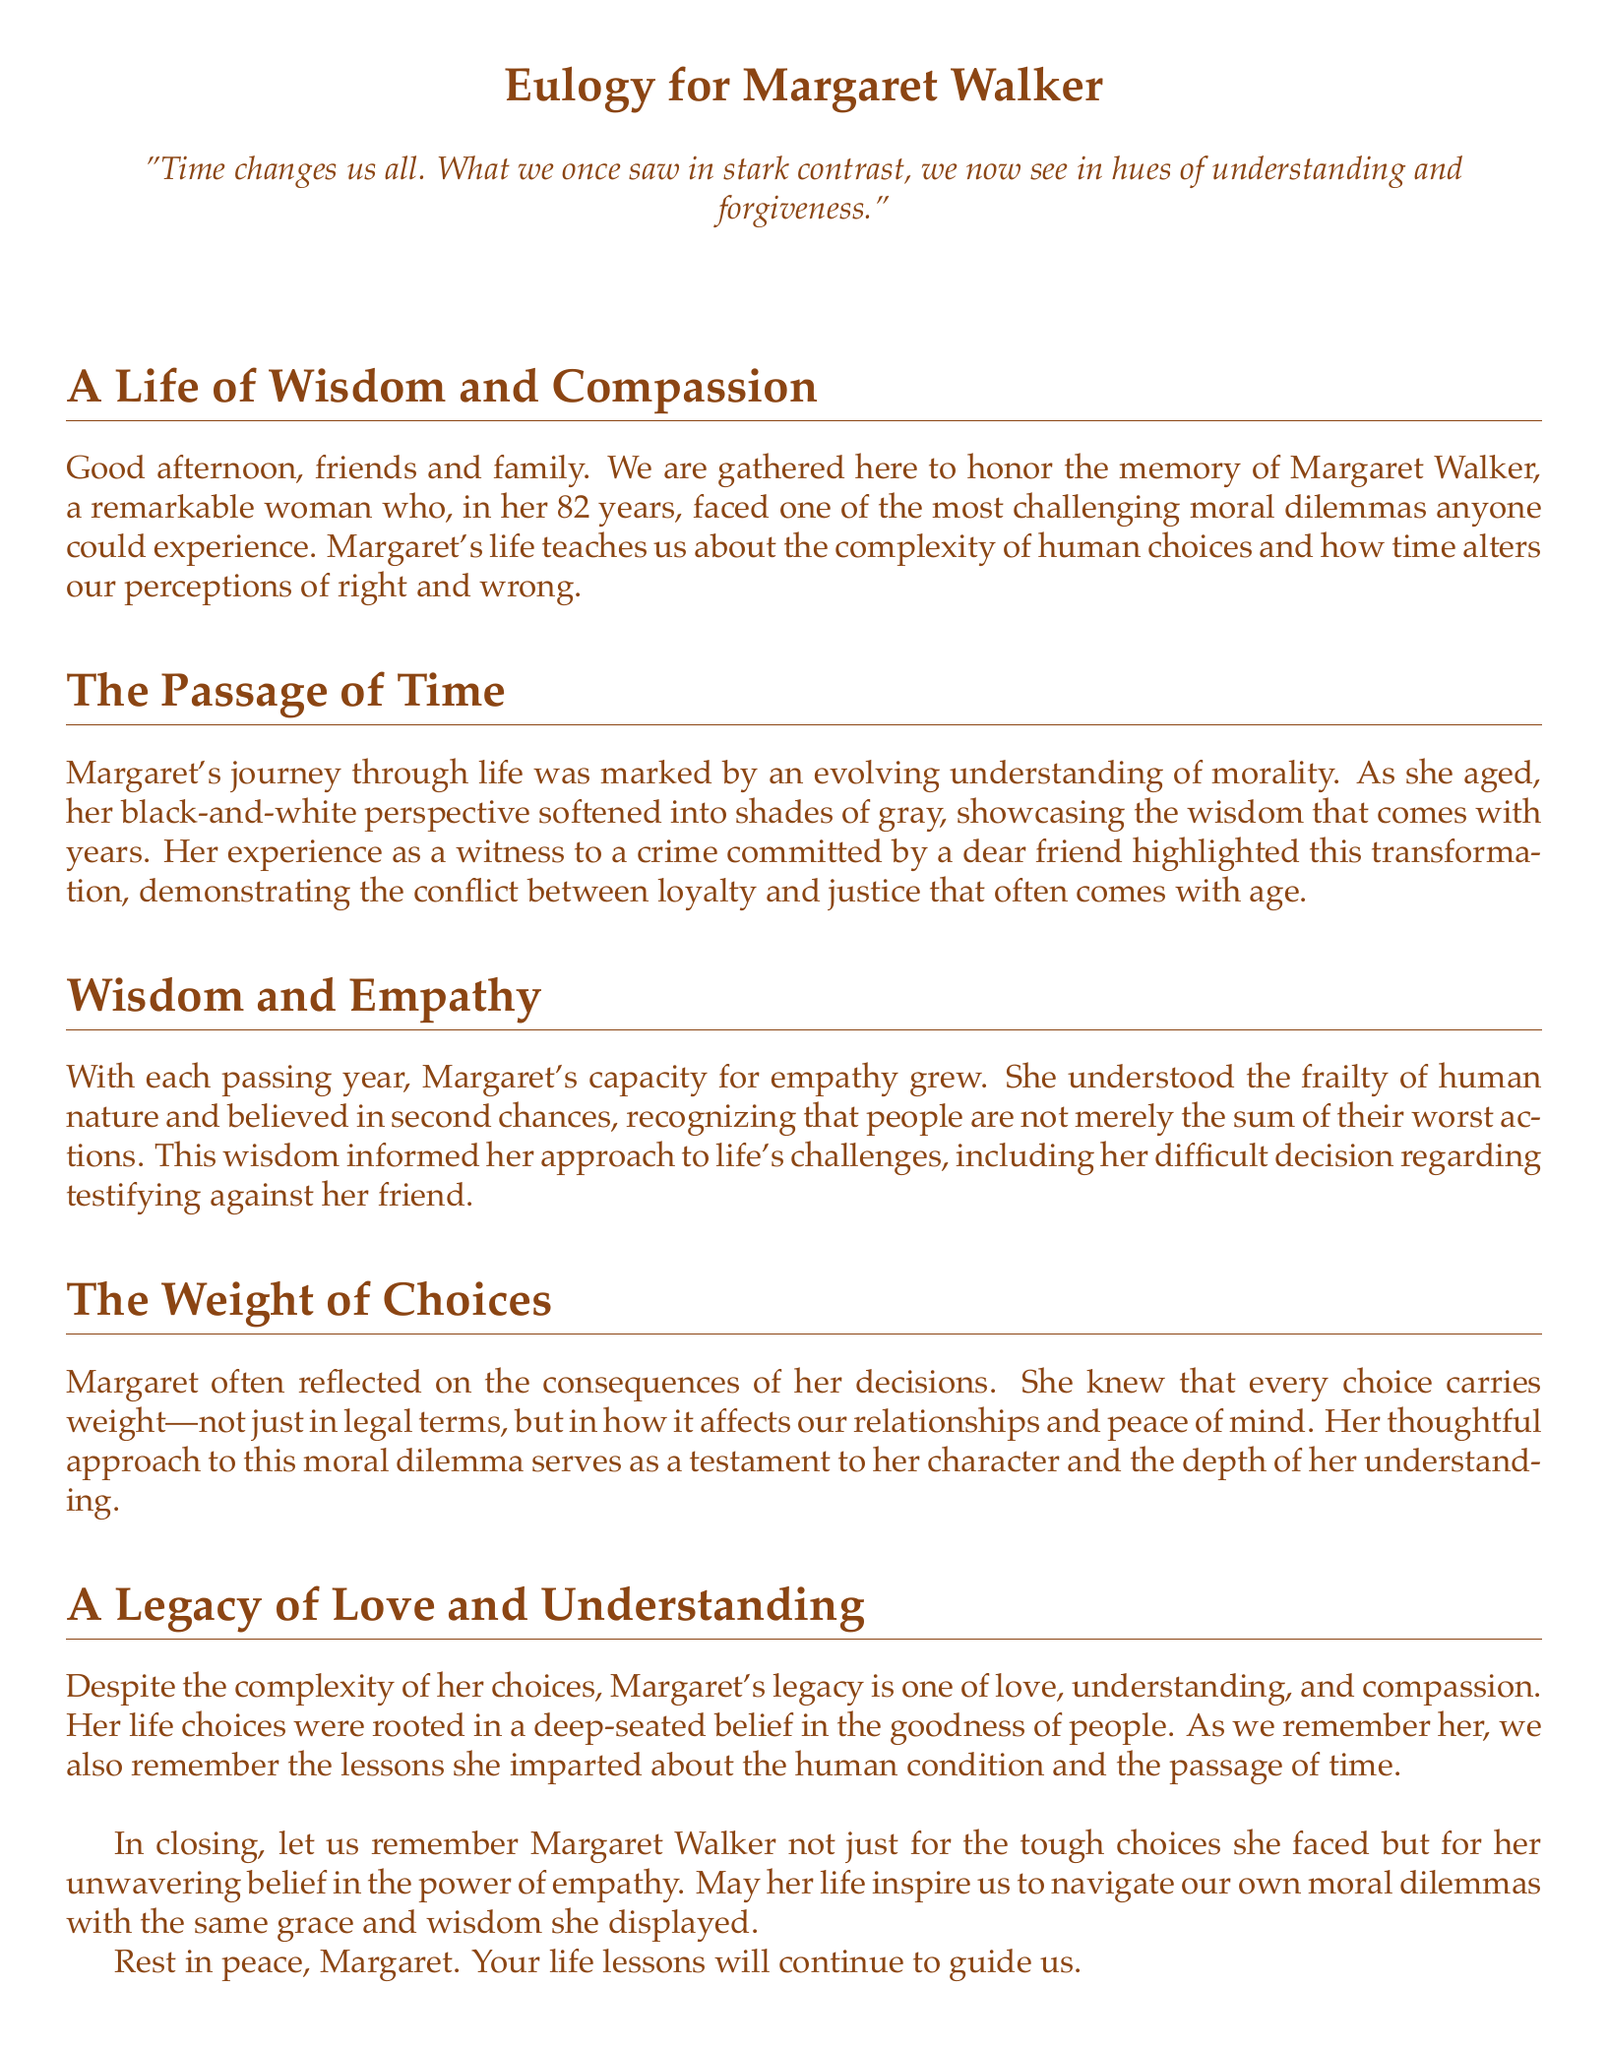what was the age of Margaret Walker at the time of her passing? The document states that Margaret lived for 82 years.
Answer: 82 what is one quote mentioned in the eulogy? The eulogy includes the quote, "Time changes us all. What we once saw in stark contrast, we now see in hues of understanding and forgiveness."
Answer: "Time changes us all. What we once saw in stark contrast, we now see in hues of understanding and forgiveness." what major dilemma did Margaret face? The eulogy discusses Margaret's decision regarding whether to testify against a dear friend after witnessing a crime.
Answer: Testifying against a friend how did Margaret's perspective on morality change over time? The document explains that her black-and-white perspective softened into shades of gray, indicating an evolving understanding of morality.
Answer: Softened into shades of gray what does the eulogy suggest is the foundation of Margaret's character? The text emphasizes that her decisions were rooted in a belief in the goodness of people, showcasing her character.
Answer: Belief in the goodness of people what is emphasized as a key aspect of Margaret's approach to empathy? The eulogy highlights that Margaret believed in second chances and recognized human frailty.
Answer: Belief in second chances how does the document characterize Margaret's legacy? The text states that despite her moral dilemmas, her legacy is one of love, understanding, and compassion.
Answer: Love, understanding, and compassion what aspect of human nature did Margaret come to understand as she aged? The eulogy points out her growing understanding of the frailty of human nature.
Answer: Frailty of human nature what overarching theme is reflected in the eulogy regarding aging? The document discusses how aging influences perceptions of right and wrong, suggesting that time brings a deeper understanding.
Answer: Perceptions of right and wrong 